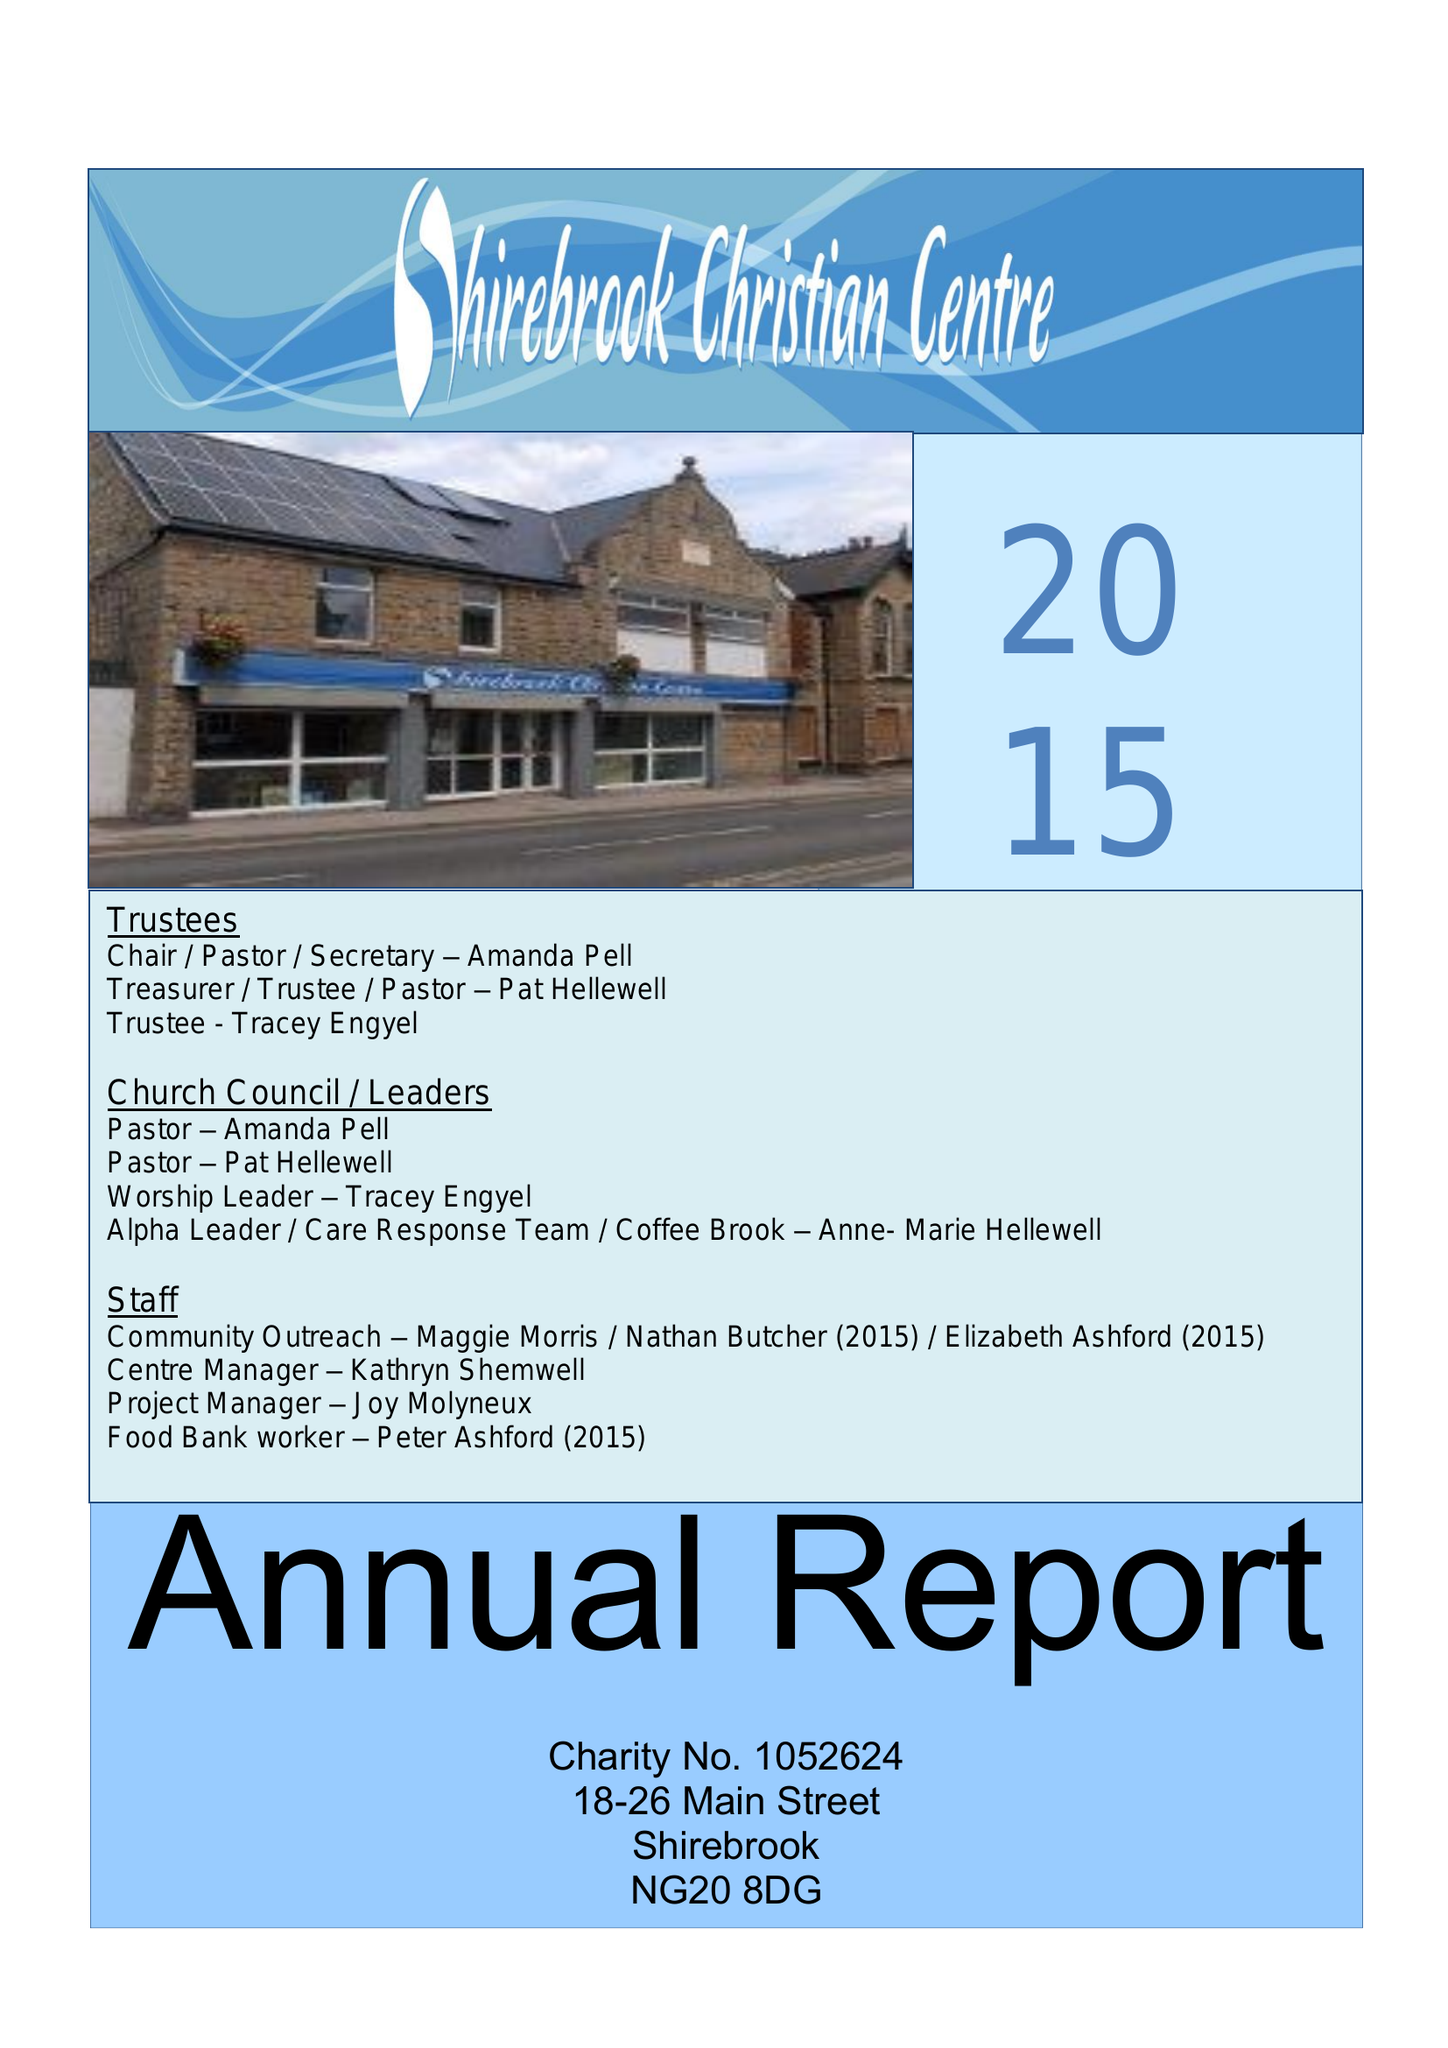What is the value for the address__postcode?
Answer the question using a single word or phrase. NG20 8DG 